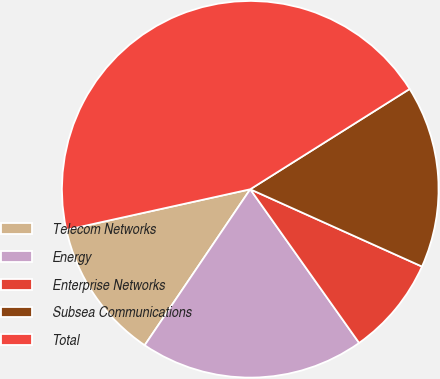<chart> <loc_0><loc_0><loc_500><loc_500><pie_chart><fcel>Telecom Networks<fcel>Energy<fcel>Enterprise Networks<fcel>Subsea Communications<fcel>Total<nl><fcel>12.07%<fcel>19.28%<fcel>8.46%<fcel>15.67%<fcel>44.52%<nl></chart> 